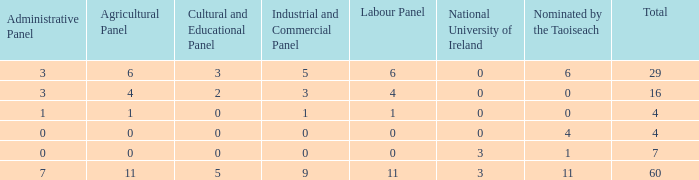What is the average administrative panel of the composition nominated by Taoiseach 0 times with a total less than 4? None. 